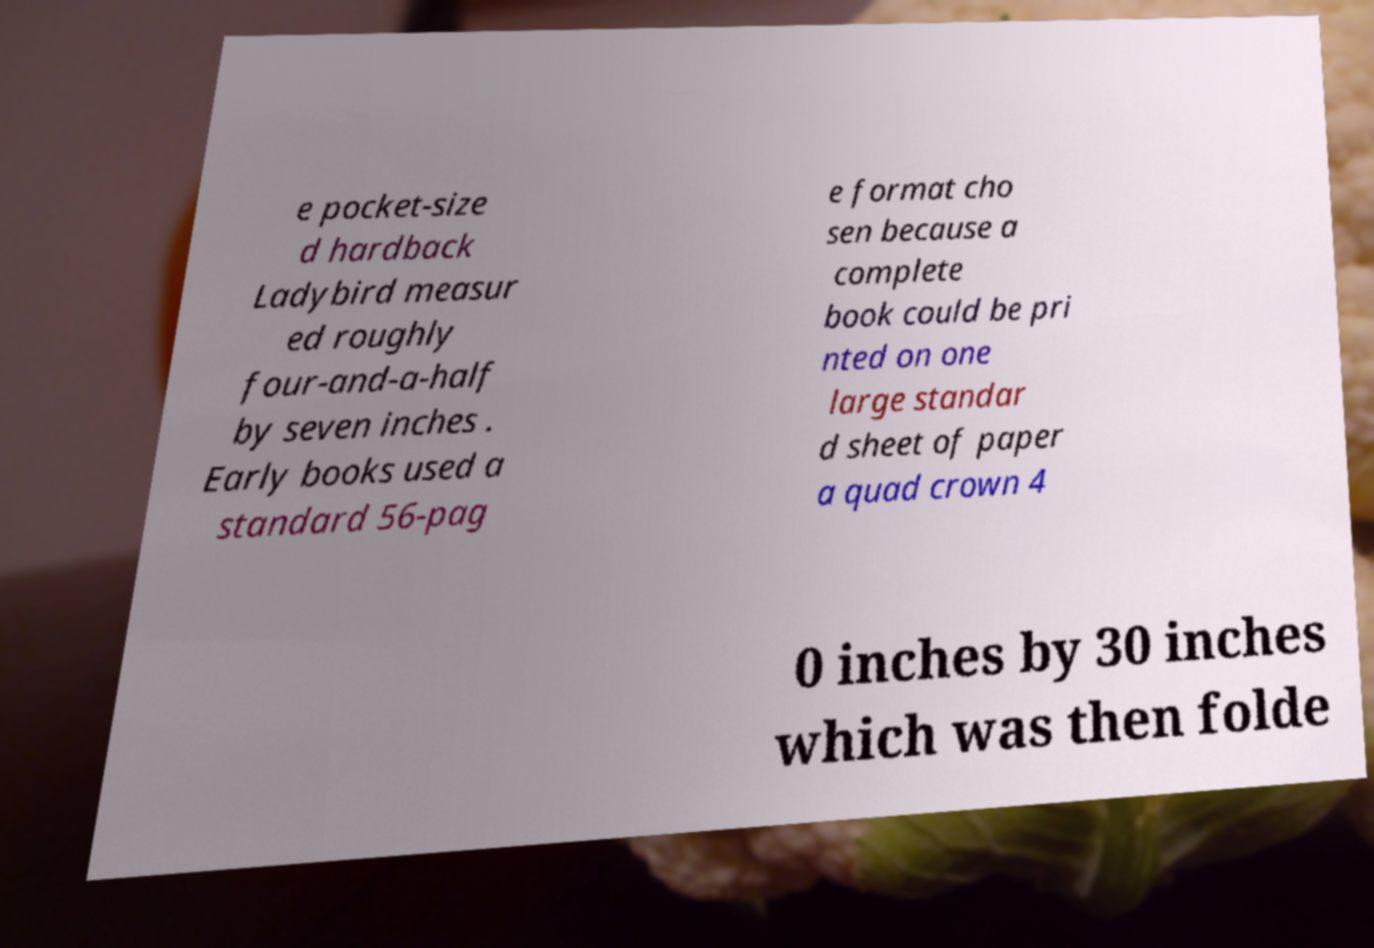Could you assist in decoding the text presented in this image and type it out clearly? e pocket-size d hardback Ladybird measur ed roughly four-and-a-half by seven inches . Early books used a standard 56-pag e format cho sen because a complete book could be pri nted on one large standar d sheet of paper a quad crown 4 0 inches by 30 inches which was then folde 